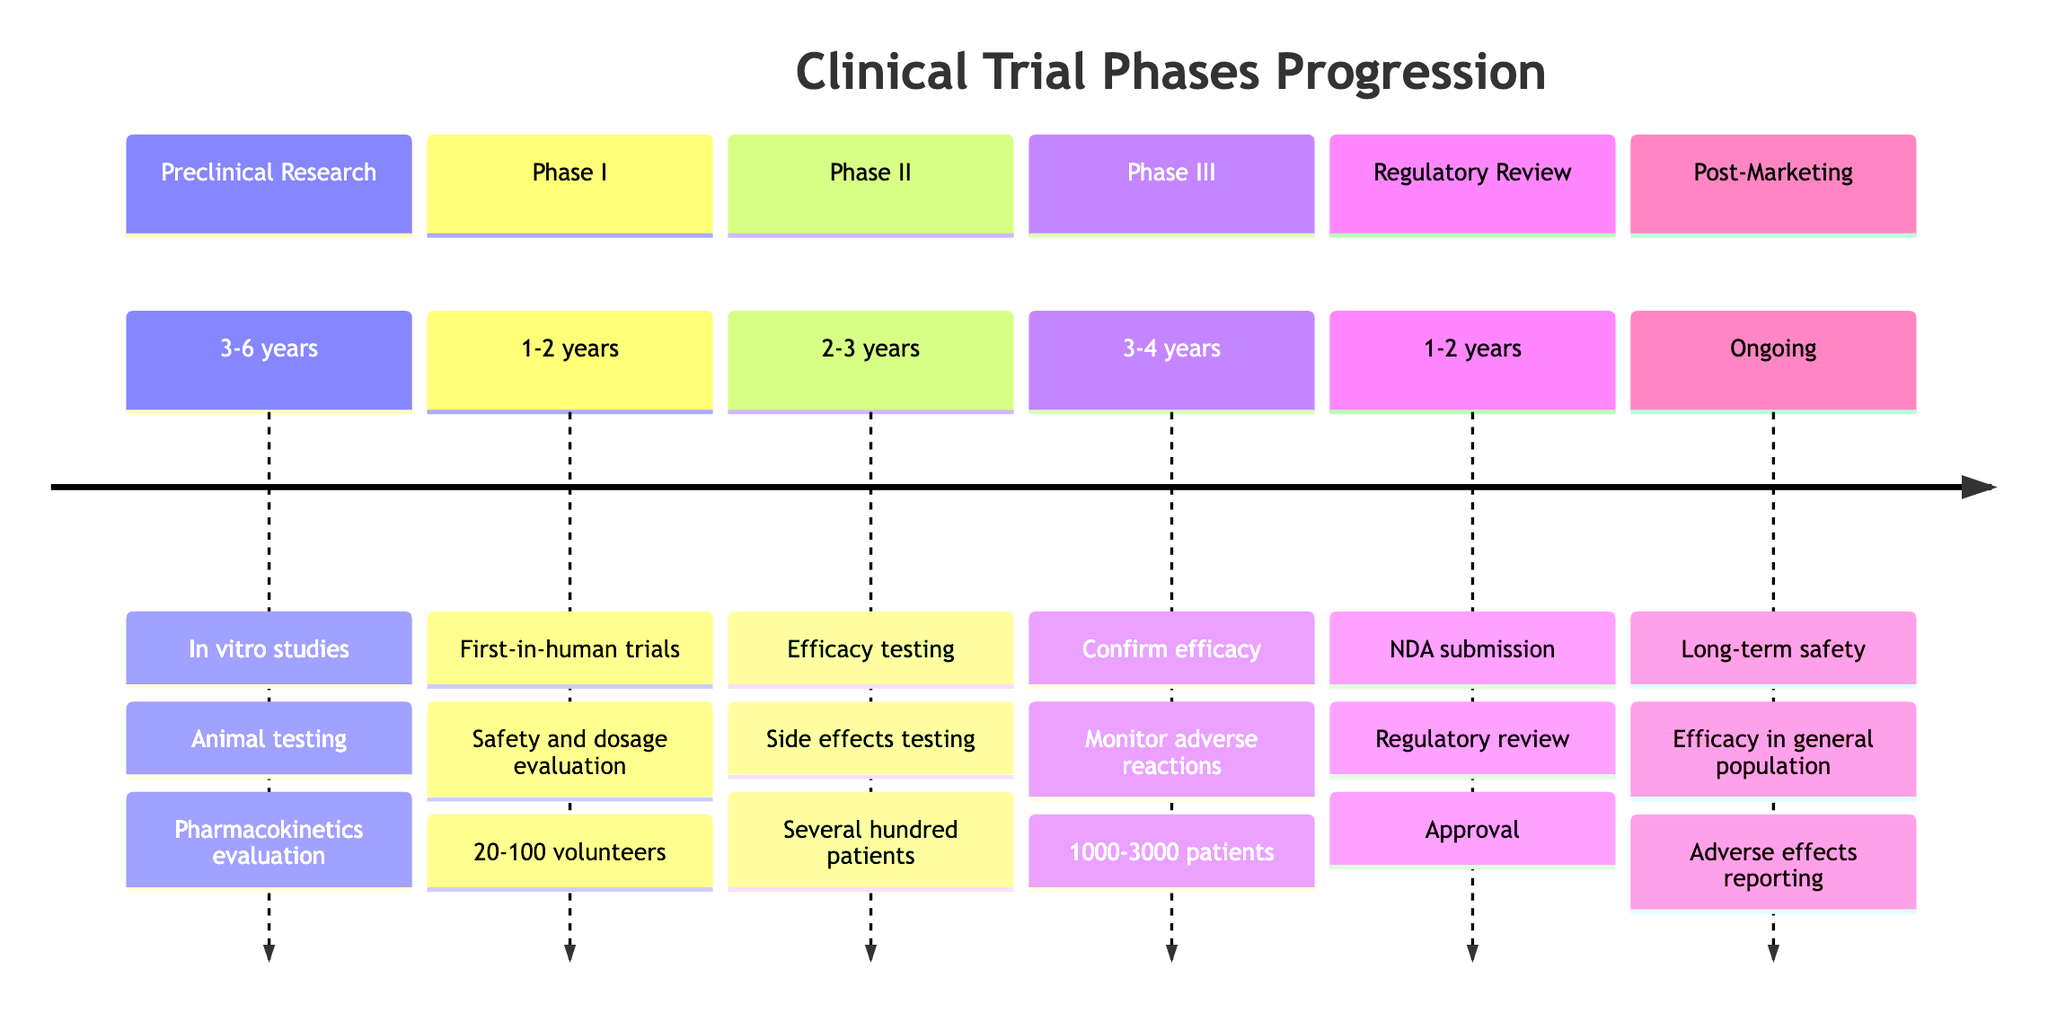What is the duration of Phase I? Referring to the timeline, Phase I is listed with a duration of 1-2 years.
Answer: 1-2 years Which phase involves first-in-human trials? The timeline highlights that Phase I includes first-in-human trials as a key activity.
Answer: Phase I How many patients are typically involved in Phase III? The timeline indicates that Phase III typically involves 1000-3000 patients.
Answer: 1000-3000 patients What is the key activity during Regulatory Review? The timeline specifies that the submission of New Drug Application (NDA) is a key activity during the Regulatory Review phase.
Answer: NDA submission Which phase includes long-term safety monitoring? The timeline lists long-term safety monitoring as a key activity in Post-Marketing Surveillance, which is Phase IV.
Answer: Post-Marketing Surveillance Which key entities are involved during Phase II? The key entities during Phase II, according to the timeline, are Clinical Trial Networks, FDA, and Insurance Companies.
Answer: Clinical Trial Networks, FDA, Insurance Companies How long does the Preclinical Research phase last? Looking at the timeline, Preclinical Research is designated a duration of 3-6 years.
Answer: 3-6 years What is the purpose of Phase II trials? The purpose of Phase II trials, as outlined in the timeline, includes efficacy and side effects testing.
Answer: Efficacy and side effects testing What comes after Phase III in the timeline? The timeline indicates that the Regulatory Review and Market Approval phase follows Phase III in the sequence.
Answer: Regulatory Review and Market Approval 